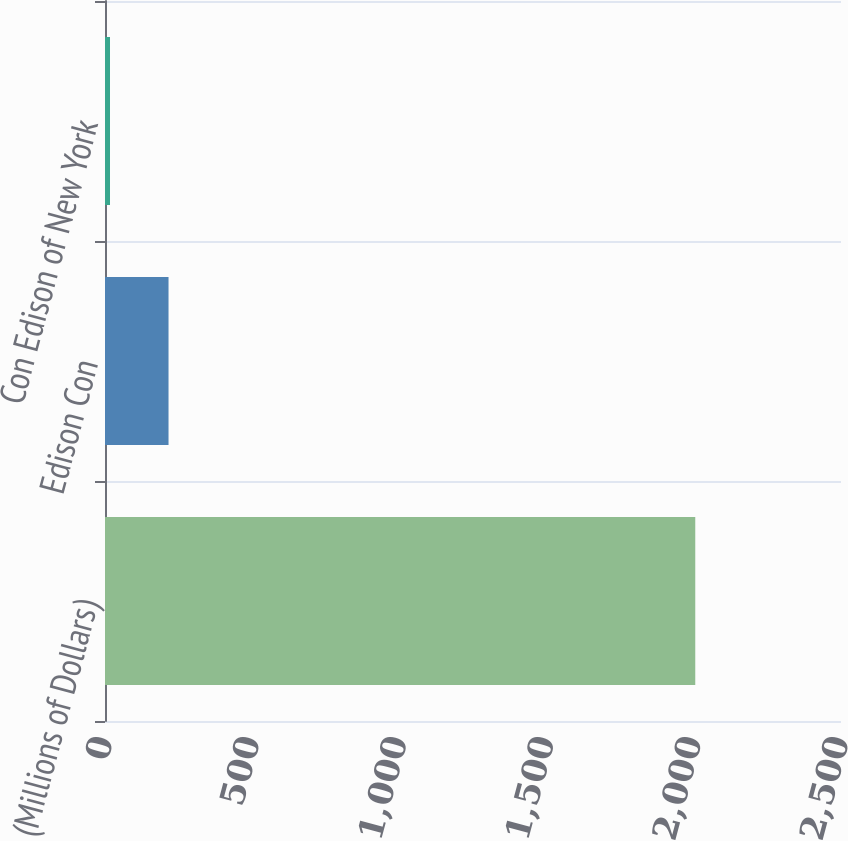<chart> <loc_0><loc_0><loc_500><loc_500><bar_chart><fcel>(Millions of Dollars)<fcel>Edison Con<fcel>Con Edison of New York<nl><fcel>2005<fcel>215.8<fcel>17<nl></chart> 